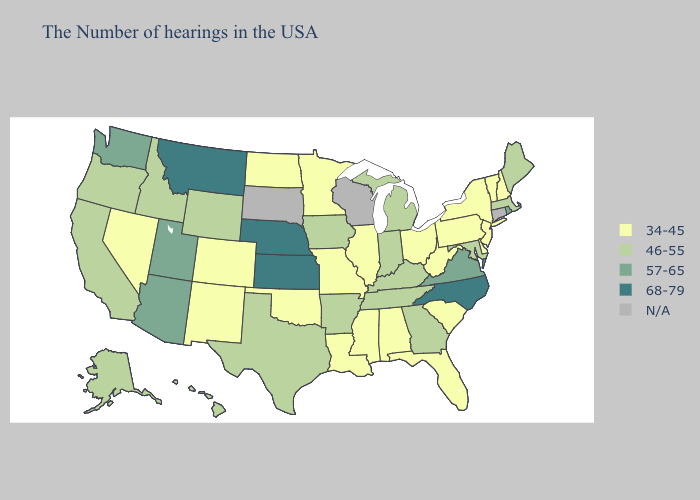What is the value of Mississippi?
Quick response, please. 34-45. What is the lowest value in states that border North Dakota?
Be succinct. 34-45. What is the highest value in the South ?
Keep it brief. 68-79. What is the lowest value in states that border Louisiana?
Keep it brief. 34-45. What is the value of Maine?
Give a very brief answer. 46-55. Name the states that have a value in the range N/A?
Keep it brief. Connecticut, Wisconsin, South Dakota. What is the value of Alabama?
Quick response, please. 34-45. What is the highest value in the USA?
Keep it brief. 68-79. What is the value of Michigan?
Be succinct. 46-55. Name the states that have a value in the range 68-79?
Short answer required. North Carolina, Kansas, Nebraska, Montana. Does Ohio have the lowest value in the MidWest?
Keep it brief. Yes. Name the states that have a value in the range 46-55?
Keep it brief. Maine, Massachusetts, Maryland, Georgia, Michigan, Kentucky, Indiana, Tennessee, Arkansas, Iowa, Texas, Wyoming, Idaho, California, Oregon, Alaska, Hawaii. What is the value of Iowa?
Be succinct. 46-55. What is the value of Nevada?
Answer briefly. 34-45. 